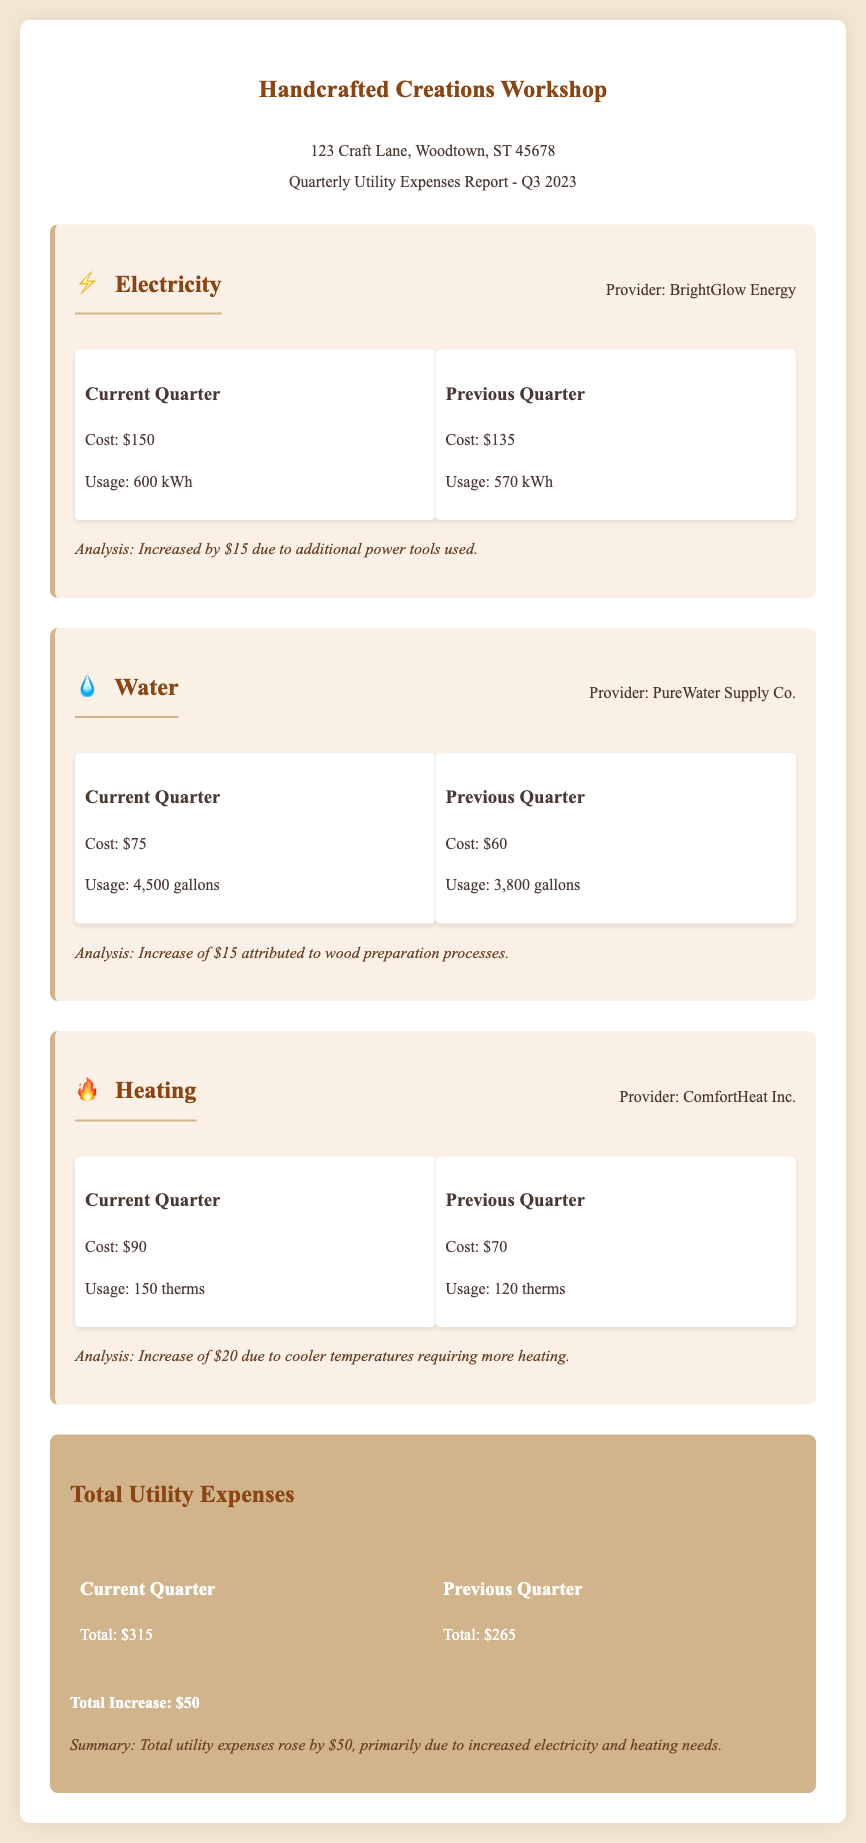What is the electricity cost for the current quarter? The current quarter electricity cost is directly stated in the document as $150.
Answer: $150 What was the total utility expense for the previous quarter? The previous quarter's total utility expense is $265, which is written in the total section of the document.
Answer: $265 What is the usage of water in the current quarter? The document specifies that the current quarter water usage is 4,500 gallons.
Answer: 4,500 gallons By how much did the heating cost increase from the previous quarter? The increase in heating cost can be calculated by comparing the costs: $90 (current) - $70 (previous) = $20.
Answer: $20 Which utility had the highest cost in the current quarter? The current quarter costs for utilities are $150 for electricity, $75 for water, and $90 for heating, making electricity the highest.
Answer: Electricity What is the provider for water supply? The document states the water provider as PureWater Supply Co.
Answer: PureWater Supply Co What is the total increase in utility expenses from the previous quarter? The total increase is calculated by subtracting the previous total ($265) from the current total ($315), which equals $50.
Answer: $50 What is the usage of electricity in the previous quarter? According to the document, the previous quarter's electricity usage is 570 kWh.
Answer: 570 kWh What analysis is provided for the water usage increase? The analysis states the increase in water usage is attributed to wood preparation processes.
Answer: Wood preparation processes 